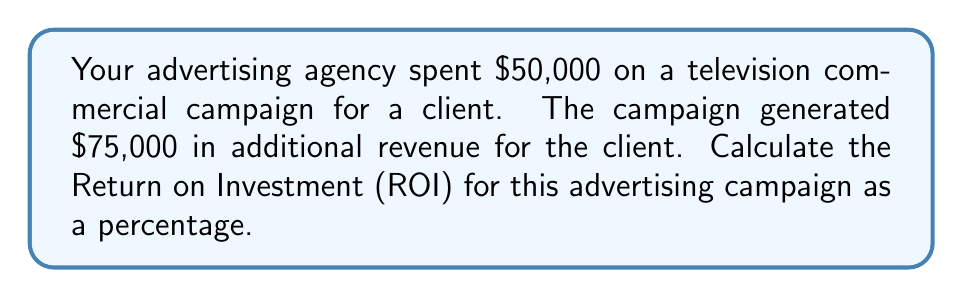Can you solve this math problem? To calculate the ROI as a percentage, we'll use the following formula:

$$ ROI (\%) = \frac{\text{Gain from Investment} - \text{Cost of Investment}}{\text{Cost of Investment}} \times 100\% $$

Let's break it down step-by-step:

1. Identify the Cost of Investment:
   $\text{Cost of Investment} = \$50,000$

2. Calculate the Gain from Investment:
   $\text{Gain from Investment} = \$75,000$

3. Calculate the numerator (Net Profit):
   $\text{Gain from Investment} - \text{Cost of Investment} = \$75,000 - \$50,000 = \$25,000$

4. Divide the Net Profit by the Cost of Investment:
   $\frac{\$25,000}{\$50,000} = 0.5$

5. Convert to a percentage by multiplying by 100%:
   $0.5 \times 100\% = 50\%$

Therefore, the ROI for this advertising campaign is 50%.
Answer: 50% 